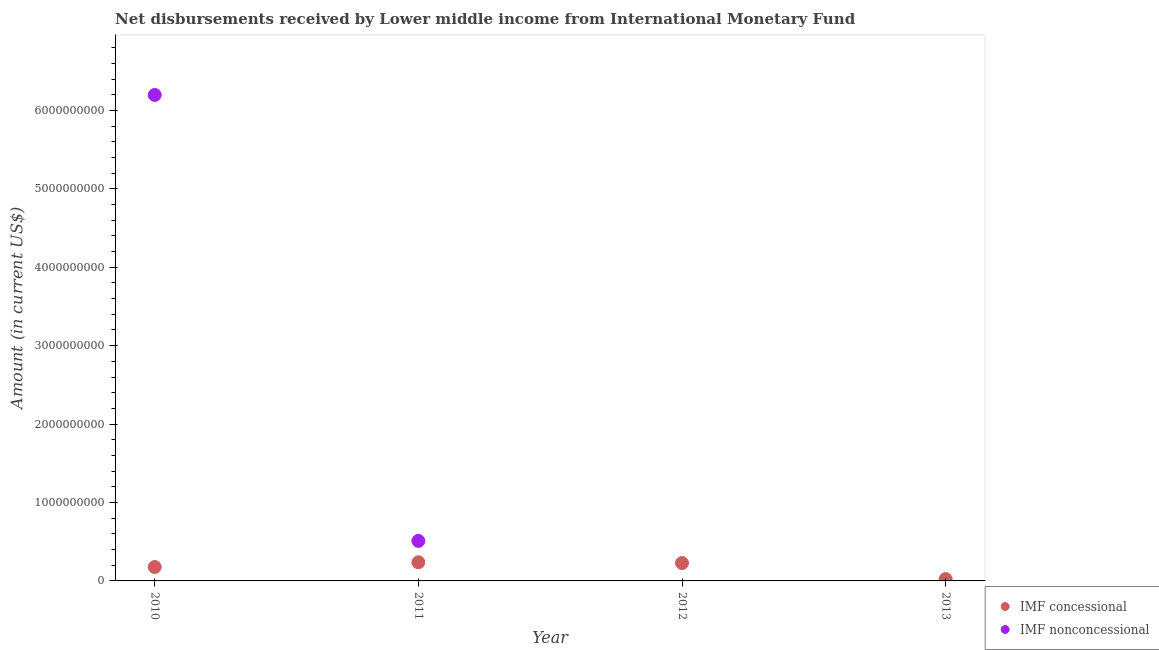What is the net concessional disbursements from imf in 2013?
Keep it short and to the point. 2.32e+07. Across all years, what is the maximum net concessional disbursements from imf?
Your answer should be very brief. 2.38e+08. Across all years, what is the minimum net non concessional disbursements from imf?
Your answer should be compact. 0. In which year was the net non concessional disbursements from imf maximum?
Make the answer very short. 2010. What is the total net concessional disbursements from imf in the graph?
Your response must be concise. 6.66e+08. What is the difference between the net concessional disbursements from imf in 2010 and that in 2013?
Ensure brevity in your answer.  1.54e+08. What is the difference between the net non concessional disbursements from imf in 2012 and the net concessional disbursements from imf in 2013?
Your answer should be compact. -2.32e+07. What is the average net non concessional disbursements from imf per year?
Ensure brevity in your answer.  1.68e+09. In the year 2011, what is the difference between the net concessional disbursements from imf and net non concessional disbursements from imf?
Make the answer very short. -2.73e+08. What is the ratio of the net concessional disbursements from imf in 2010 to that in 2011?
Make the answer very short. 0.75. Is the net non concessional disbursements from imf in 2010 less than that in 2011?
Your answer should be compact. No. What is the difference between the highest and the second highest net concessional disbursements from imf?
Your response must be concise. 9.87e+06. What is the difference between the highest and the lowest net non concessional disbursements from imf?
Provide a succinct answer. 6.20e+09. Is the net non concessional disbursements from imf strictly greater than the net concessional disbursements from imf over the years?
Make the answer very short. No. Is the net non concessional disbursements from imf strictly less than the net concessional disbursements from imf over the years?
Offer a very short reply. No. How many years are there in the graph?
Offer a terse response. 4. What is the difference between two consecutive major ticks on the Y-axis?
Offer a very short reply. 1.00e+09. Are the values on the major ticks of Y-axis written in scientific E-notation?
Your response must be concise. No. Where does the legend appear in the graph?
Your answer should be compact. Bottom right. How many legend labels are there?
Give a very brief answer. 2. How are the legend labels stacked?
Your answer should be very brief. Vertical. What is the title of the graph?
Make the answer very short. Net disbursements received by Lower middle income from International Monetary Fund. Does "Secondary education" appear as one of the legend labels in the graph?
Your answer should be compact. No. What is the label or title of the Y-axis?
Provide a succinct answer. Amount (in current US$). What is the Amount (in current US$) in IMF concessional in 2010?
Keep it short and to the point. 1.77e+08. What is the Amount (in current US$) in IMF nonconcessional in 2010?
Offer a terse response. 6.20e+09. What is the Amount (in current US$) of IMF concessional in 2011?
Offer a terse response. 2.38e+08. What is the Amount (in current US$) in IMF nonconcessional in 2011?
Make the answer very short. 5.10e+08. What is the Amount (in current US$) of IMF concessional in 2012?
Give a very brief answer. 2.28e+08. What is the Amount (in current US$) in IMF concessional in 2013?
Provide a short and direct response. 2.32e+07. Across all years, what is the maximum Amount (in current US$) of IMF concessional?
Provide a succinct answer. 2.38e+08. Across all years, what is the maximum Amount (in current US$) in IMF nonconcessional?
Keep it short and to the point. 6.20e+09. Across all years, what is the minimum Amount (in current US$) in IMF concessional?
Your answer should be compact. 2.32e+07. What is the total Amount (in current US$) in IMF concessional in the graph?
Keep it short and to the point. 6.66e+08. What is the total Amount (in current US$) in IMF nonconcessional in the graph?
Provide a succinct answer. 6.71e+09. What is the difference between the Amount (in current US$) in IMF concessional in 2010 and that in 2011?
Your response must be concise. -6.04e+07. What is the difference between the Amount (in current US$) in IMF nonconcessional in 2010 and that in 2011?
Make the answer very short. 5.69e+09. What is the difference between the Amount (in current US$) in IMF concessional in 2010 and that in 2012?
Offer a terse response. -5.05e+07. What is the difference between the Amount (in current US$) of IMF concessional in 2010 and that in 2013?
Offer a terse response. 1.54e+08. What is the difference between the Amount (in current US$) in IMF concessional in 2011 and that in 2012?
Make the answer very short. 9.87e+06. What is the difference between the Amount (in current US$) of IMF concessional in 2011 and that in 2013?
Offer a very short reply. 2.14e+08. What is the difference between the Amount (in current US$) in IMF concessional in 2012 and that in 2013?
Ensure brevity in your answer.  2.05e+08. What is the difference between the Amount (in current US$) in IMF concessional in 2010 and the Amount (in current US$) in IMF nonconcessional in 2011?
Your answer should be compact. -3.33e+08. What is the average Amount (in current US$) of IMF concessional per year?
Your answer should be compact. 1.66e+08. What is the average Amount (in current US$) of IMF nonconcessional per year?
Provide a succinct answer. 1.68e+09. In the year 2010, what is the difference between the Amount (in current US$) in IMF concessional and Amount (in current US$) in IMF nonconcessional?
Provide a succinct answer. -6.02e+09. In the year 2011, what is the difference between the Amount (in current US$) in IMF concessional and Amount (in current US$) in IMF nonconcessional?
Provide a succinct answer. -2.73e+08. What is the ratio of the Amount (in current US$) in IMF concessional in 2010 to that in 2011?
Keep it short and to the point. 0.75. What is the ratio of the Amount (in current US$) of IMF nonconcessional in 2010 to that in 2011?
Ensure brevity in your answer.  12.14. What is the ratio of the Amount (in current US$) in IMF concessional in 2010 to that in 2012?
Your response must be concise. 0.78. What is the ratio of the Amount (in current US$) in IMF concessional in 2010 to that in 2013?
Offer a very short reply. 7.65. What is the ratio of the Amount (in current US$) in IMF concessional in 2011 to that in 2012?
Your response must be concise. 1.04. What is the ratio of the Amount (in current US$) of IMF concessional in 2011 to that in 2013?
Offer a terse response. 10.26. What is the ratio of the Amount (in current US$) of IMF concessional in 2012 to that in 2013?
Keep it short and to the point. 9.83. What is the difference between the highest and the second highest Amount (in current US$) in IMF concessional?
Your response must be concise. 9.87e+06. What is the difference between the highest and the lowest Amount (in current US$) in IMF concessional?
Make the answer very short. 2.14e+08. What is the difference between the highest and the lowest Amount (in current US$) in IMF nonconcessional?
Provide a succinct answer. 6.20e+09. 